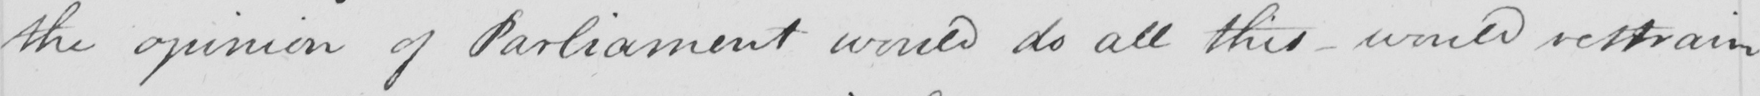Can you read and transcribe this handwriting? the opinion of Parliament would do all this  _  would restrain 